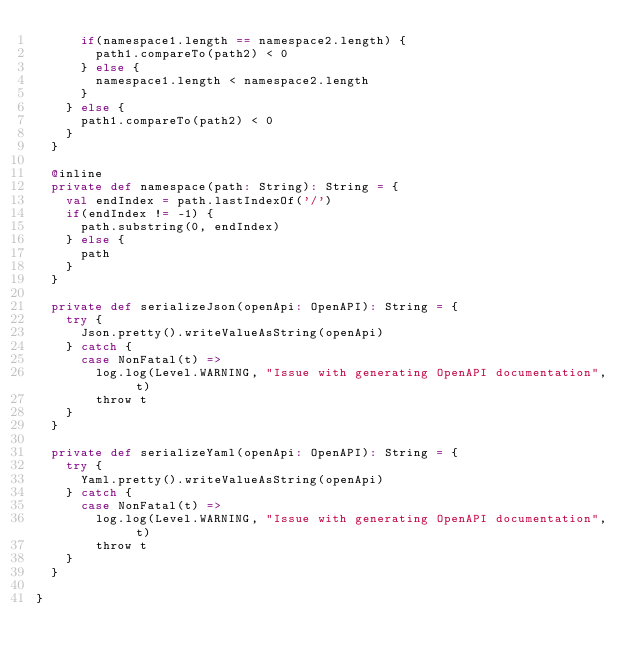<code> <loc_0><loc_0><loc_500><loc_500><_Scala_>      if(namespace1.length == namespace2.length) {
        path1.compareTo(path2) < 0
      } else {
        namespace1.length < namespace2.length
      }
    } else {
      path1.compareTo(path2) < 0
    }
  }

  @inline
  private def namespace(path: String): String = {
    val endIndex = path.lastIndexOf('/')
    if(endIndex != -1) {
      path.substring(0, endIndex)
    } else {
      path
    }
  }

  private def serializeJson(openApi: OpenAPI): String = {
    try {
      Json.pretty().writeValueAsString(openApi)
    } catch {
      case NonFatal(t) =>
        log.log(Level.WARNING, "Issue with generating OpenAPI documentation", t)
        throw t
    }
  }

  private def serializeYaml(openApi: OpenAPI): String = {
    try {
      Yaml.pretty().writeValueAsString(openApi)
    } catch {
      case NonFatal(t) =>
        log.log(Level.WARNING, "Issue with generating OpenAPI documentation", t)
        throw t
    }
  }

}</code> 